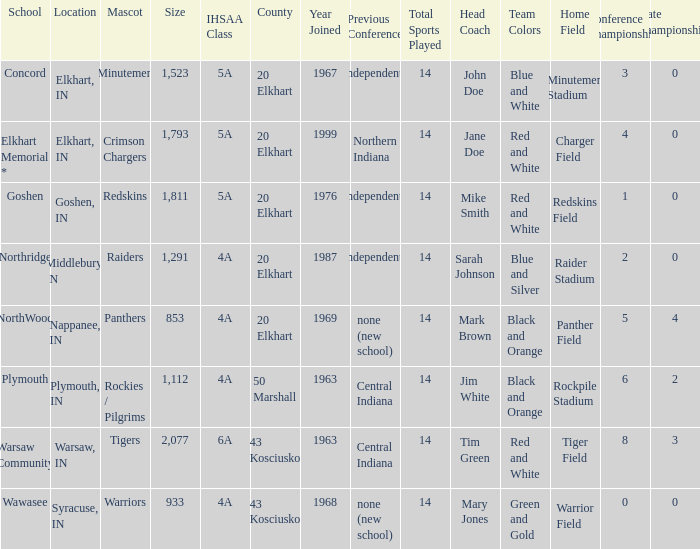What country joined before 1976, with IHSSA class of 5a, and a size larger than 1,112? 20 Elkhart. 